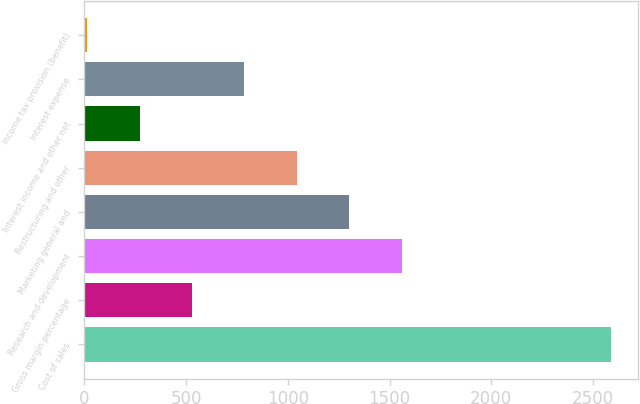<chart> <loc_0><loc_0><loc_500><loc_500><bar_chart><fcel>Cost of sales<fcel>Gross margin percentage<fcel>Research and development<fcel>Marketing general and<fcel>Restructuring and other<fcel>Interest income and other net<fcel>Interest expense<fcel>Income tax provision (benefit)<nl><fcel>2590<fcel>529.2<fcel>1559.6<fcel>1302<fcel>1044.4<fcel>271.6<fcel>786.8<fcel>14<nl></chart> 